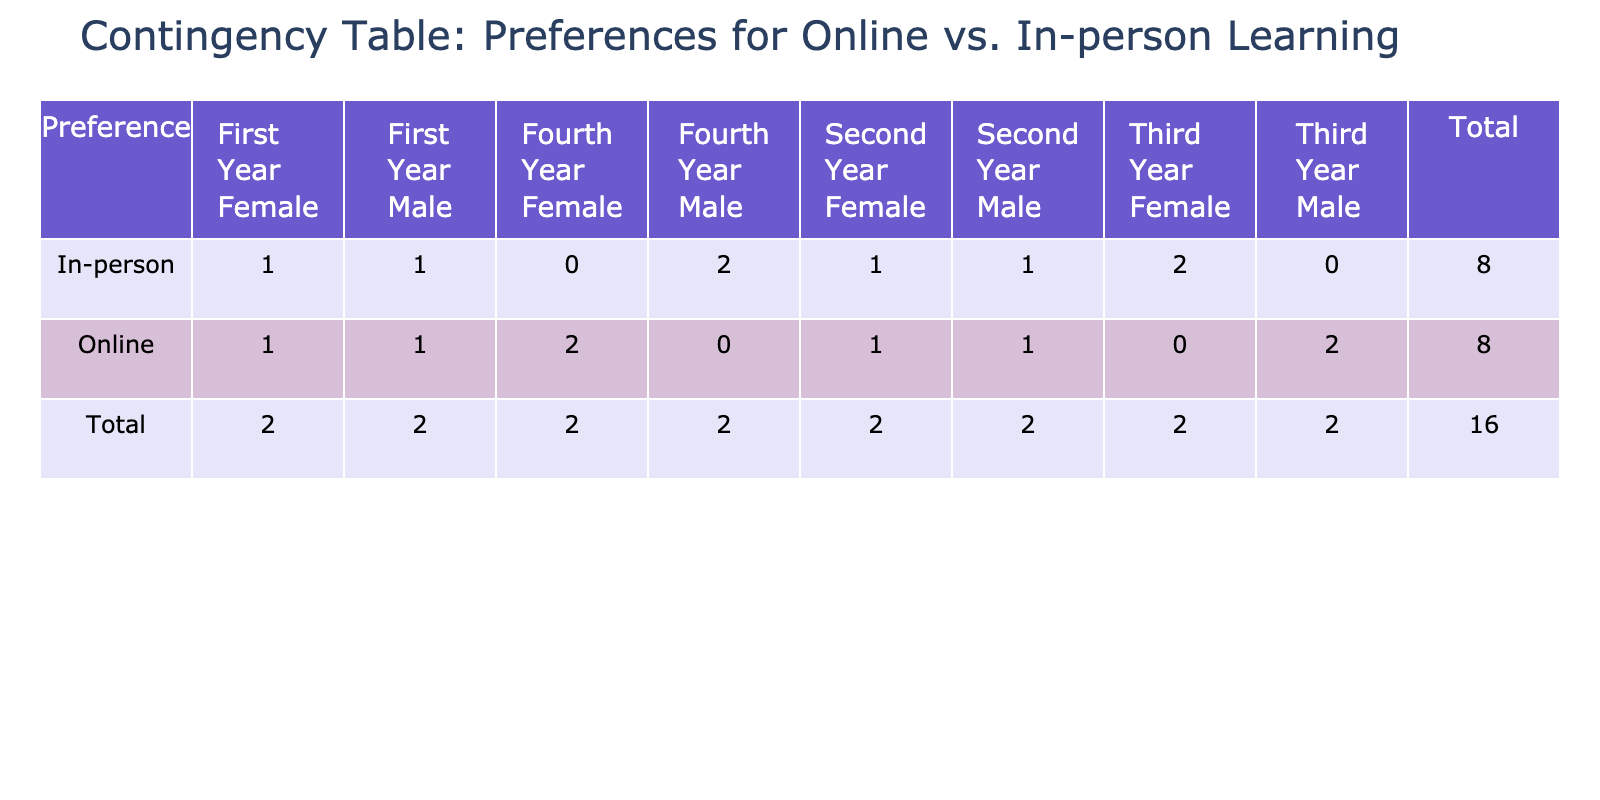What is the total number of students who prefer online learning? By looking at the "Online" row in the contingency table, I can see that the total for that row is 7.
Answer: 7 What is the total number of students who prefer in-person learning? By looking at the "In-person" row in the contingency table, I can see that the total for that row is 8.
Answer: 8 How many male students prefer in-person learning in their first year? Referring to the "In-person First Year Male" cell in the table, there is 1 male student who prefers in-person learning in their first year.
Answer: 1 Are there any female students in the third year who prefer in-person learning? Checking the "In-person Third Year Female" cell, there is 1 female student who prefers in-person learning in the third year. Hence, the answer is yes.
Answer: Yes What is the difference in the number of students who prefer online learning versus in-person learning in the second year? From the table, "Online Second Year" has 1 student, and "In-person Second Year" has 2 students. Therefore, the difference is 1 - 2 = -1 (indicating more in-person learners)
Answer: -1 How many female students prefer online learning across all years? The total for "Online" for females can be calculated: 3 (First Year) + 1 (Second Year) + 1 (Third Year) + 2 (Fourth Year) = 7.
Answer: 7 What proportion of first-year students prefer online learning? Looking at the total for first-year students, the count is 2 (1 Male Online + 1 Female In-person). Out of these, 1 prefers online, thus, the proportion is 1/2 = 0.5.
Answer: 0.5 Is there an equal number of male and female students in any year who prefer online learning? The only year where equal numbers of males and females prefer online learning is in the Fourth Year, with 2 females and 1 male, so the answer is no.
Answer: No How many students overall prefer online learning in years other than the first year? Looking at the data, the counts are: Online Second Year has 1, Online Third Year has 2, and Online Fourth Year has 2. Adding these gives 1 + 2 + 2 = 5.
Answer: 5 What is the total number of students in the fourth year? Referring to the fourth year data, the total is 1 (Online Female) + 1 (In-person Male) = 2 students.
Answer: 2 